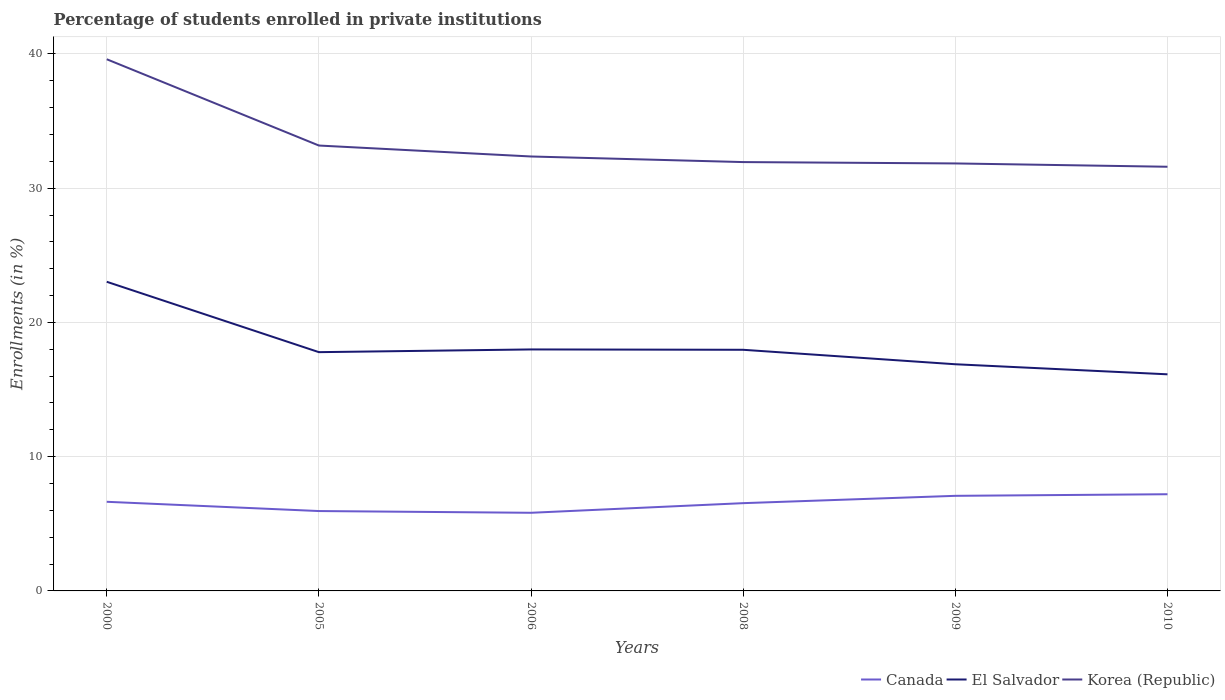How many different coloured lines are there?
Your answer should be compact. 3. Does the line corresponding to El Salvador intersect with the line corresponding to Canada?
Your answer should be very brief. No. Across all years, what is the maximum percentage of trained teachers in Canada?
Ensure brevity in your answer.  5.82. In which year was the percentage of trained teachers in El Salvador maximum?
Your answer should be very brief. 2010. What is the total percentage of trained teachers in Canada in the graph?
Your answer should be compact. -0.44. What is the difference between the highest and the second highest percentage of trained teachers in Korea (Republic)?
Keep it short and to the point. 8.01. What is the difference between the highest and the lowest percentage of trained teachers in Canada?
Your response must be concise. 3. Is the percentage of trained teachers in Korea (Republic) strictly greater than the percentage of trained teachers in El Salvador over the years?
Your response must be concise. No. How many years are there in the graph?
Keep it short and to the point. 6. How many legend labels are there?
Keep it short and to the point. 3. How are the legend labels stacked?
Ensure brevity in your answer.  Horizontal. What is the title of the graph?
Give a very brief answer. Percentage of students enrolled in private institutions. What is the label or title of the X-axis?
Give a very brief answer. Years. What is the label or title of the Y-axis?
Offer a very short reply. Enrollments (in %). What is the Enrollments (in %) of Canada in 2000?
Provide a short and direct response. 6.64. What is the Enrollments (in %) in El Salvador in 2000?
Your answer should be very brief. 23.03. What is the Enrollments (in %) of Korea (Republic) in 2000?
Your answer should be very brief. 39.6. What is the Enrollments (in %) of Canada in 2005?
Offer a terse response. 5.95. What is the Enrollments (in %) of El Salvador in 2005?
Your answer should be compact. 17.79. What is the Enrollments (in %) of Korea (Republic) in 2005?
Your response must be concise. 33.18. What is the Enrollments (in %) in Canada in 2006?
Your answer should be compact. 5.82. What is the Enrollments (in %) in El Salvador in 2006?
Keep it short and to the point. 17.99. What is the Enrollments (in %) in Korea (Republic) in 2006?
Provide a short and direct response. 32.36. What is the Enrollments (in %) of Canada in 2008?
Make the answer very short. 6.54. What is the Enrollments (in %) of El Salvador in 2008?
Provide a succinct answer. 17.96. What is the Enrollments (in %) in Korea (Republic) in 2008?
Keep it short and to the point. 31.94. What is the Enrollments (in %) of Canada in 2009?
Offer a very short reply. 7.08. What is the Enrollments (in %) in El Salvador in 2009?
Provide a short and direct response. 16.88. What is the Enrollments (in %) of Korea (Republic) in 2009?
Ensure brevity in your answer.  31.84. What is the Enrollments (in %) in Canada in 2010?
Offer a terse response. 7.2. What is the Enrollments (in %) in El Salvador in 2010?
Your answer should be very brief. 16.14. What is the Enrollments (in %) of Korea (Republic) in 2010?
Offer a very short reply. 31.6. Across all years, what is the maximum Enrollments (in %) in Canada?
Provide a short and direct response. 7.2. Across all years, what is the maximum Enrollments (in %) in El Salvador?
Keep it short and to the point. 23.03. Across all years, what is the maximum Enrollments (in %) in Korea (Republic)?
Offer a terse response. 39.6. Across all years, what is the minimum Enrollments (in %) of Canada?
Provide a short and direct response. 5.82. Across all years, what is the minimum Enrollments (in %) of El Salvador?
Keep it short and to the point. 16.14. Across all years, what is the minimum Enrollments (in %) in Korea (Republic)?
Keep it short and to the point. 31.6. What is the total Enrollments (in %) of Canada in the graph?
Your answer should be compact. 39.23. What is the total Enrollments (in %) of El Salvador in the graph?
Your response must be concise. 109.78. What is the total Enrollments (in %) in Korea (Republic) in the graph?
Your response must be concise. 200.53. What is the difference between the Enrollments (in %) of Canada in 2000 and that in 2005?
Make the answer very short. 0.69. What is the difference between the Enrollments (in %) of El Salvador in 2000 and that in 2005?
Provide a short and direct response. 5.24. What is the difference between the Enrollments (in %) in Korea (Republic) in 2000 and that in 2005?
Your answer should be compact. 6.43. What is the difference between the Enrollments (in %) in Canada in 2000 and that in 2006?
Offer a very short reply. 0.82. What is the difference between the Enrollments (in %) of El Salvador in 2000 and that in 2006?
Make the answer very short. 5.04. What is the difference between the Enrollments (in %) in Korea (Republic) in 2000 and that in 2006?
Offer a terse response. 7.24. What is the difference between the Enrollments (in %) of Canada in 2000 and that in 2008?
Provide a short and direct response. 0.1. What is the difference between the Enrollments (in %) in El Salvador in 2000 and that in 2008?
Your answer should be very brief. 5.07. What is the difference between the Enrollments (in %) in Korea (Republic) in 2000 and that in 2008?
Your answer should be very brief. 7.66. What is the difference between the Enrollments (in %) of Canada in 2000 and that in 2009?
Ensure brevity in your answer.  -0.44. What is the difference between the Enrollments (in %) of El Salvador in 2000 and that in 2009?
Provide a succinct answer. 6.14. What is the difference between the Enrollments (in %) in Korea (Republic) in 2000 and that in 2009?
Give a very brief answer. 7.76. What is the difference between the Enrollments (in %) of Canada in 2000 and that in 2010?
Keep it short and to the point. -0.56. What is the difference between the Enrollments (in %) in El Salvador in 2000 and that in 2010?
Give a very brief answer. 6.89. What is the difference between the Enrollments (in %) in Korea (Republic) in 2000 and that in 2010?
Your answer should be very brief. 8.01. What is the difference between the Enrollments (in %) of Canada in 2005 and that in 2006?
Ensure brevity in your answer.  0.13. What is the difference between the Enrollments (in %) of El Salvador in 2005 and that in 2006?
Offer a very short reply. -0.2. What is the difference between the Enrollments (in %) in Korea (Republic) in 2005 and that in 2006?
Give a very brief answer. 0.82. What is the difference between the Enrollments (in %) of Canada in 2005 and that in 2008?
Offer a terse response. -0.59. What is the difference between the Enrollments (in %) of El Salvador in 2005 and that in 2008?
Your answer should be compact. -0.18. What is the difference between the Enrollments (in %) in Korea (Republic) in 2005 and that in 2008?
Offer a terse response. 1.23. What is the difference between the Enrollments (in %) in Canada in 2005 and that in 2009?
Your answer should be very brief. -1.13. What is the difference between the Enrollments (in %) in El Salvador in 2005 and that in 2009?
Provide a short and direct response. 0.9. What is the difference between the Enrollments (in %) of Korea (Republic) in 2005 and that in 2009?
Provide a short and direct response. 1.33. What is the difference between the Enrollments (in %) in Canada in 2005 and that in 2010?
Provide a succinct answer. -1.25. What is the difference between the Enrollments (in %) in El Salvador in 2005 and that in 2010?
Make the answer very short. 1.65. What is the difference between the Enrollments (in %) in Korea (Republic) in 2005 and that in 2010?
Provide a succinct answer. 1.58. What is the difference between the Enrollments (in %) of Canada in 2006 and that in 2008?
Ensure brevity in your answer.  -0.72. What is the difference between the Enrollments (in %) in El Salvador in 2006 and that in 2008?
Ensure brevity in your answer.  0.03. What is the difference between the Enrollments (in %) in Korea (Republic) in 2006 and that in 2008?
Provide a short and direct response. 0.42. What is the difference between the Enrollments (in %) of Canada in 2006 and that in 2009?
Your answer should be very brief. -1.26. What is the difference between the Enrollments (in %) of El Salvador in 2006 and that in 2009?
Offer a very short reply. 1.1. What is the difference between the Enrollments (in %) of Korea (Republic) in 2006 and that in 2009?
Ensure brevity in your answer.  0.52. What is the difference between the Enrollments (in %) of Canada in 2006 and that in 2010?
Offer a terse response. -1.38. What is the difference between the Enrollments (in %) in El Salvador in 2006 and that in 2010?
Provide a succinct answer. 1.85. What is the difference between the Enrollments (in %) of Korea (Republic) in 2006 and that in 2010?
Make the answer very short. 0.76. What is the difference between the Enrollments (in %) in Canada in 2008 and that in 2009?
Offer a very short reply. -0.55. What is the difference between the Enrollments (in %) of El Salvador in 2008 and that in 2009?
Make the answer very short. 1.08. What is the difference between the Enrollments (in %) in Korea (Republic) in 2008 and that in 2009?
Provide a succinct answer. 0.1. What is the difference between the Enrollments (in %) in Canada in 2008 and that in 2010?
Your response must be concise. -0.67. What is the difference between the Enrollments (in %) of El Salvador in 2008 and that in 2010?
Provide a succinct answer. 1.83. What is the difference between the Enrollments (in %) of Korea (Republic) in 2008 and that in 2010?
Ensure brevity in your answer.  0.35. What is the difference between the Enrollments (in %) of Canada in 2009 and that in 2010?
Offer a very short reply. -0.12. What is the difference between the Enrollments (in %) of El Salvador in 2009 and that in 2010?
Keep it short and to the point. 0.75. What is the difference between the Enrollments (in %) of Korea (Republic) in 2009 and that in 2010?
Ensure brevity in your answer.  0.25. What is the difference between the Enrollments (in %) of Canada in 2000 and the Enrollments (in %) of El Salvador in 2005?
Your answer should be very brief. -11.15. What is the difference between the Enrollments (in %) in Canada in 2000 and the Enrollments (in %) in Korea (Republic) in 2005?
Your answer should be compact. -26.54. What is the difference between the Enrollments (in %) in El Salvador in 2000 and the Enrollments (in %) in Korea (Republic) in 2005?
Offer a terse response. -10.15. What is the difference between the Enrollments (in %) in Canada in 2000 and the Enrollments (in %) in El Salvador in 2006?
Your answer should be compact. -11.35. What is the difference between the Enrollments (in %) in Canada in 2000 and the Enrollments (in %) in Korea (Republic) in 2006?
Your answer should be very brief. -25.72. What is the difference between the Enrollments (in %) of El Salvador in 2000 and the Enrollments (in %) of Korea (Republic) in 2006?
Make the answer very short. -9.33. What is the difference between the Enrollments (in %) of Canada in 2000 and the Enrollments (in %) of El Salvador in 2008?
Your answer should be very brief. -11.32. What is the difference between the Enrollments (in %) of Canada in 2000 and the Enrollments (in %) of Korea (Republic) in 2008?
Keep it short and to the point. -25.3. What is the difference between the Enrollments (in %) of El Salvador in 2000 and the Enrollments (in %) of Korea (Republic) in 2008?
Your response must be concise. -8.92. What is the difference between the Enrollments (in %) of Canada in 2000 and the Enrollments (in %) of El Salvador in 2009?
Offer a terse response. -10.24. What is the difference between the Enrollments (in %) of Canada in 2000 and the Enrollments (in %) of Korea (Republic) in 2009?
Your answer should be compact. -25.2. What is the difference between the Enrollments (in %) in El Salvador in 2000 and the Enrollments (in %) in Korea (Republic) in 2009?
Provide a succinct answer. -8.81. What is the difference between the Enrollments (in %) of Canada in 2000 and the Enrollments (in %) of El Salvador in 2010?
Your answer should be very brief. -9.5. What is the difference between the Enrollments (in %) in Canada in 2000 and the Enrollments (in %) in Korea (Republic) in 2010?
Ensure brevity in your answer.  -24.96. What is the difference between the Enrollments (in %) of El Salvador in 2000 and the Enrollments (in %) of Korea (Republic) in 2010?
Make the answer very short. -8.57. What is the difference between the Enrollments (in %) in Canada in 2005 and the Enrollments (in %) in El Salvador in 2006?
Make the answer very short. -12.04. What is the difference between the Enrollments (in %) of Canada in 2005 and the Enrollments (in %) of Korea (Republic) in 2006?
Keep it short and to the point. -26.41. What is the difference between the Enrollments (in %) in El Salvador in 2005 and the Enrollments (in %) in Korea (Republic) in 2006?
Your answer should be very brief. -14.57. What is the difference between the Enrollments (in %) of Canada in 2005 and the Enrollments (in %) of El Salvador in 2008?
Offer a very short reply. -12.01. What is the difference between the Enrollments (in %) in Canada in 2005 and the Enrollments (in %) in Korea (Republic) in 2008?
Make the answer very short. -25.99. What is the difference between the Enrollments (in %) in El Salvador in 2005 and the Enrollments (in %) in Korea (Republic) in 2008?
Keep it short and to the point. -14.16. What is the difference between the Enrollments (in %) in Canada in 2005 and the Enrollments (in %) in El Salvador in 2009?
Make the answer very short. -10.93. What is the difference between the Enrollments (in %) of Canada in 2005 and the Enrollments (in %) of Korea (Republic) in 2009?
Keep it short and to the point. -25.89. What is the difference between the Enrollments (in %) in El Salvador in 2005 and the Enrollments (in %) in Korea (Republic) in 2009?
Your answer should be compact. -14.06. What is the difference between the Enrollments (in %) in Canada in 2005 and the Enrollments (in %) in El Salvador in 2010?
Make the answer very short. -10.19. What is the difference between the Enrollments (in %) in Canada in 2005 and the Enrollments (in %) in Korea (Republic) in 2010?
Your response must be concise. -25.65. What is the difference between the Enrollments (in %) of El Salvador in 2005 and the Enrollments (in %) of Korea (Republic) in 2010?
Make the answer very short. -13.81. What is the difference between the Enrollments (in %) of Canada in 2006 and the Enrollments (in %) of El Salvador in 2008?
Give a very brief answer. -12.14. What is the difference between the Enrollments (in %) of Canada in 2006 and the Enrollments (in %) of Korea (Republic) in 2008?
Your answer should be very brief. -26.12. What is the difference between the Enrollments (in %) of El Salvador in 2006 and the Enrollments (in %) of Korea (Republic) in 2008?
Offer a very short reply. -13.96. What is the difference between the Enrollments (in %) of Canada in 2006 and the Enrollments (in %) of El Salvador in 2009?
Your answer should be compact. -11.06. What is the difference between the Enrollments (in %) of Canada in 2006 and the Enrollments (in %) of Korea (Republic) in 2009?
Offer a terse response. -26.02. What is the difference between the Enrollments (in %) in El Salvador in 2006 and the Enrollments (in %) in Korea (Republic) in 2009?
Your response must be concise. -13.85. What is the difference between the Enrollments (in %) of Canada in 2006 and the Enrollments (in %) of El Salvador in 2010?
Make the answer very short. -10.32. What is the difference between the Enrollments (in %) in Canada in 2006 and the Enrollments (in %) in Korea (Republic) in 2010?
Give a very brief answer. -25.78. What is the difference between the Enrollments (in %) in El Salvador in 2006 and the Enrollments (in %) in Korea (Republic) in 2010?
Offer a very short reply. -13.61. What is the difference between the Enrollments (in %) in Canada in 2008 and the Enrollments (in %) in El Salvador in 2009?
Your response must be concise. -10.35. What is the difference between the Enrollments (in %) in Canada in 2008 and the Enrollments (in %) in Korea (Republic) in 2009?
Keep it short and to the point. -25.31. What is the difference between the Enrollments (in %) of El Salvador in 2008 and the Enrollments (in %) of Korea (Republic) in 2009?
Offer a terse response. -13.88. What is the difference between the Enrollments (in %) of Canada in 2008 and the Enrollments (in %) of El Salvador in 2010?
Provide a succinct answer. -9.6. What is the difference between the Enrollments (in %) in Canada in 2008 and the Enrollments (in %) in Korea (Republic) in 2010?
Make the answer very short. -25.06. What is the difference between the Enrollments (in %) of El Salvador in 2008 and the Enrollments (in %) of Korea (Republic) in 2010?
Offer a terse response. -13.63. What is the difference between the Enrollments (in %) of Canada in 2009 and the Enrollments (in %) of El Salvador in 2010?
Provide a succinct answer. -9.05. What is the difference between the Enrollments (in %) of Canada in 2009 and the Enrollments (in %) of Korea (Republic) in 2010?
Your response must be concise. -24.51. What is the difference between the Enrollments (in %) of El Salvador in 2009 and the Enrollments (in %) of Korea (Republic) in 2010?
Offer a terse response. -14.71. What is the average Enrollments (in %) of Canada per year?
Your response must be concise. 6.54. What is the average Enrollments (in %) in El Salvador per year?
Your answer should be compact. 18.3. What is the average Enrollments (in %) of Korea (Republic) per year?
Ensure brevity in your answer.  33.42. In the year 2000, what is the difference between the Enrollments (in %) in Canada and Enrollments (in %) in El Salvador?
Your answer should be very brief. -16.39. In the year 2000, what is the difference between the Enrollments (in %) in Canada and Enrollments (in %) in Korea (Republic)?
Ensure brevity in your answer.  -32.96. In the year 2000, what is the difference between the Enrollments (in %) in El Salvador and Enrollments (in %) in Korea (Republic)?
Give a very brief answer. -16.58. In the year 2005, what is the difference between the Enrollments (in %) in Canada and Enrollments (in %) in El Salvador?
Your response must be concise. -11.84. In the year 2005, what is the difference between the Enrollments (in %) in Canada and Enrollments (in %) in Korea (Republic)?
Keep it short and to the point. -27.23. In the year 2005, what is the difference between the Enrollments (in %) in El Salvador and Enrollments (in %) in Korea (Republic)?
Offer a terse response. -15.39. In the year 2006, what is the difference between the Enrollments (in %) in Canada and Enrollments (in %) in El Salvador?
Your answer should be compact. -12.17. In the year 2006, what is the difference between the Enrollments (in %) of Canada and Enrollments (in %) of Korea (Republic)?
Make the answer very short. -26.54. In the year 2006, what is the difference between the Enrollments (in %) of El Salvador and Enrollments (in %) of Korea (Republic)?
Keep it short and to the point. -14.37. In the year 2008, what is the difference between the Enrollments (in %) of Canada and Enrollments (in %) of El Salvador?
Provide a short and direct response. -11.42. In the year 2008, what is the difference between the Enrollments (in %) of Canada and Enrollments (in %) of Korea (Republic)?
Make the answer very short. -25.41. In the year 2008, what is the difference between the Enrollments (in %) in El Salvador and Enrollments (in %) in Korea (Republic)?
Ensure brevity in your answer.  -13.98. In the year 2009, what is the difference between the Enrollments (in %) in Canada and Enrollments (in %) in El Salvador?
Your answer should be compact. -9.8. In the year 2009, what is the difference between the Enrollments (in %) of Canada and Enrollments (in %) of Korea (Republic)?
Offer a terse response. -24.76. In the year 2009, what is the difference between the Enrollments (in %) of El Salvador and Enrollments (in %) of Korea (Republic)?
Provide a succinct answer. -14.96. In the year 2010, what is the difference between the Enrollments (in %) in Canada and Enrollments (in %) in El Salvador?
Your answer should be compact. -8.93. In the year 2010, what is the difference between the Enrollments (in %) of Canada and Enrollments (in %) of Korea (Republic)?
Your answer should be compact. -24.39. In the year 2010, what is the difference between the Enrollments (in %) of El Salvador and Enrollments (in %) of Korea (Republic)?
Provide a succinct answer. -15.46. What is the ratio of the Enrollments (in %) of Canada in 2000 to that in 2005?
Your answer should be compact. 1.12. What is the ratio of the Enrollments (in %) of El Salvador in 2000 to that in 2005?
Offer a terse response. 1.29. What is the ratio of the Enrollments (in %) of Korea (Republic) in 2000 to that in 2005?
Offer a very short reply. 1.19. What is the ratio of the Enrollments (in %) of Canada in 2000 to that in 2006?
Your answer should be very brief. 1.14. What is the ratio of the Enrollments (in %) in El Salvador in 2000 to that in 2006?
Provide a short and direct response. 1.28. What is the ratio of the Enrollments (in %) in Korea (Republic) in 2000 to that in 2006?
Offer a very short reply. 1.22. What is the ratio of the Enrollments (in %) in Canada in 2000 to that in 2008?
Ensure brevity in your answer.  1.02. What is the ratio of the Enrollments (in %) in El Salvador in 2000 to that in 2008?
Your answer should be compact. 1.28. What is the ratio of the Enrollments (in %) of Korea (Republic) in 2000 to that in 2008?
Keep it short and to the point. 1.24. What is the ratio of the Enrollments (in %) of Canada in 2000 to that in 2009?
Give a very brief answer. 0.94. What is the ratio of the Enrollments (in %) of El Salvador in 2000 to that in 2009?
Offer a terse response. 1.36. What is the ratio of the Enrollments (in %) of Korea (Republic) in 2000 to that in 2009?
Offer a very short reply. 1.24. What is the ratio of the Enrollments (in %) of Canada in 2000 to that in 2010?
Ensure brevity in your answer.  0.92. What is the ratio of the Enrollments (in %) of El Salvador in 2000 to that in 2010?
Ensure brevity in your answer.  1.43. What is the ratio of the Enrollments (in %) of Korea (Republic) in 2000 to that in 2010?
Keep it short and to the point. 1.25. What is the ratio of the Enrollments (in %) in Canada in 2005 to that in 2006?
Provide a short and direct response. 1.02. What is the ratio of the Enrollments (in %) in El Salvador in 2005 to that in 2006?
Offer a very short reply. 0.99. What is the ratio of the Enrollments (in %) in Korea (Republic) in 2005 to that in 2006?
Give a very brief answer. 1.03. What is the ratio of the Enrollments (in %) in Canada in 2005 to that in 2008?
Provide a short and direct response. 0.91. What is the ratio of the Enrollments (in %) in El Salvador in 2005 to that in 2008?
Ensure brevity in your answer.  0.99. What is the ratio of the Enrollments (in %) in Korea (Republic) in 2005 to that in 2008?
Offer a terse response. 1.04. What is the ratio of the Enrollments (in %) of Canada in 2005 to that in 2009?
Your response must be concise. 0.84. What is the ratio of the Enrollments (in %) in El Salvador in 2005 to that in 2009?
Your response must be concise. 1.05. What is the ratio of the Enrollments (in %) of Korea (Republic) in 2005 to that in 2009?
Offer a terse response. 1.04. What is the ratio of the Enrollments (in %) in Canada in 2005 to that in 2010?
Keep it short and to the point. 0.83. What is the ratio of the Enrollments (in %) of El Salvador in 2005 to that in 2010?
Make the answer very short. 1.1. What is the ratio of the Enrollments (in %) in Korea (Republic) in 2005 to that in 2010?
Make the answer very short. 1.05. What is the ratio of the Enrollments (in %) of Canada in 2006 to that in 2008?
Provide a succinct answer. 0.89. What is the ratio of the Enrollments (in %) of El Salvador in 2006 to that in 2008?
Offer a very short reply. 1. What is the ratio of the Enrollments (in %) in Canada in 2006 to that in 2009?
Offer a terse response. 0.82. What is the ratio of the Enrollments (in %) in El Salvador in 2006 to that in 2009?
Offer a very short reply. 1.07. What is the ratio of the Enrollments (in %) of Korea (Republic) in 2006 to that in 2009?
Your answer should be very brief. 1.02. What is the ratio of the Enrollments (in %) of Canada in 2006 to that in 2010?
Your answer should be very brief. 0.81. What is the ratio of the Enrollments (in %) in El Salvador in 2006 to that in 2010?
Keep it short and to the point. 1.11. What is the ratio of the Enrollments (in %) of Korea (Republic) in 2006 to that in 2010?
Your answer should be very brief. 1.02. What is the ratio of the Enrollments (in %) of Canada in 2008 to that in 2009?
Keep it short and to the point. 0.92. What is the ratio of the Enrollments (in %) of El Salvador in 2008 to that in 2009?
Your answer should be compact. 1.06. What is the ratio of the Enrollments (in %) in Korea (Republic) in 2008 to that in 2009?
Ensure brevity in your answer.  1. What is the ratio of the Enrollments (in %) in Canada in 2008 to that in 2010?
Provide a short and direct response. 0.91. What is the ratio of the Enrollments (in %) in El Salvador in 2008 to that in 2010?
Your answer should be very brief. 1.11. What is the ratio of the Enrollments (in %) in Korea (Republic) in 2008 to that in 2010?
Make the answer very short. 1.01. What is the ratio of the Enrollments (in %) in Canada in 2009 to that in 2010?
Keep it short and to the point. 0.98. What is the ratio of the Enrollments (in %) of El Salvador in 2009 to that in 2010?
Provide a short and direct response. 1.05. What is the ratio of the Enrollments (in %) of Korea (Republic) in 2009 to that in 2010?
Your response must be concise. 1.01. What is the difference between the highest and the second highest Enrollments (in %) of Canada?
Ensure brevity in your answer.  0.12. What is the difference between the highest and the second highest Enrollments (in %) in El Salvador?
Keep it short and to the point. 5.04. What is the difference between the highest and the second highest Enrollments (in %) of Korea (Republic)?
Make the answer very short. 6.43. What is the difference between the highest and the lowest Enrollments (in %) in Canada?
Offer a very short reply. 1.38. What is the difference between the highest and the lowest Enrollments (in %) in El Salvador?
Make the answer very short. 6.89. What is the difference between the highest and the lowest Enrollments (in %) of Korea (Republic)?
Your answer should be compact. 8.01. 